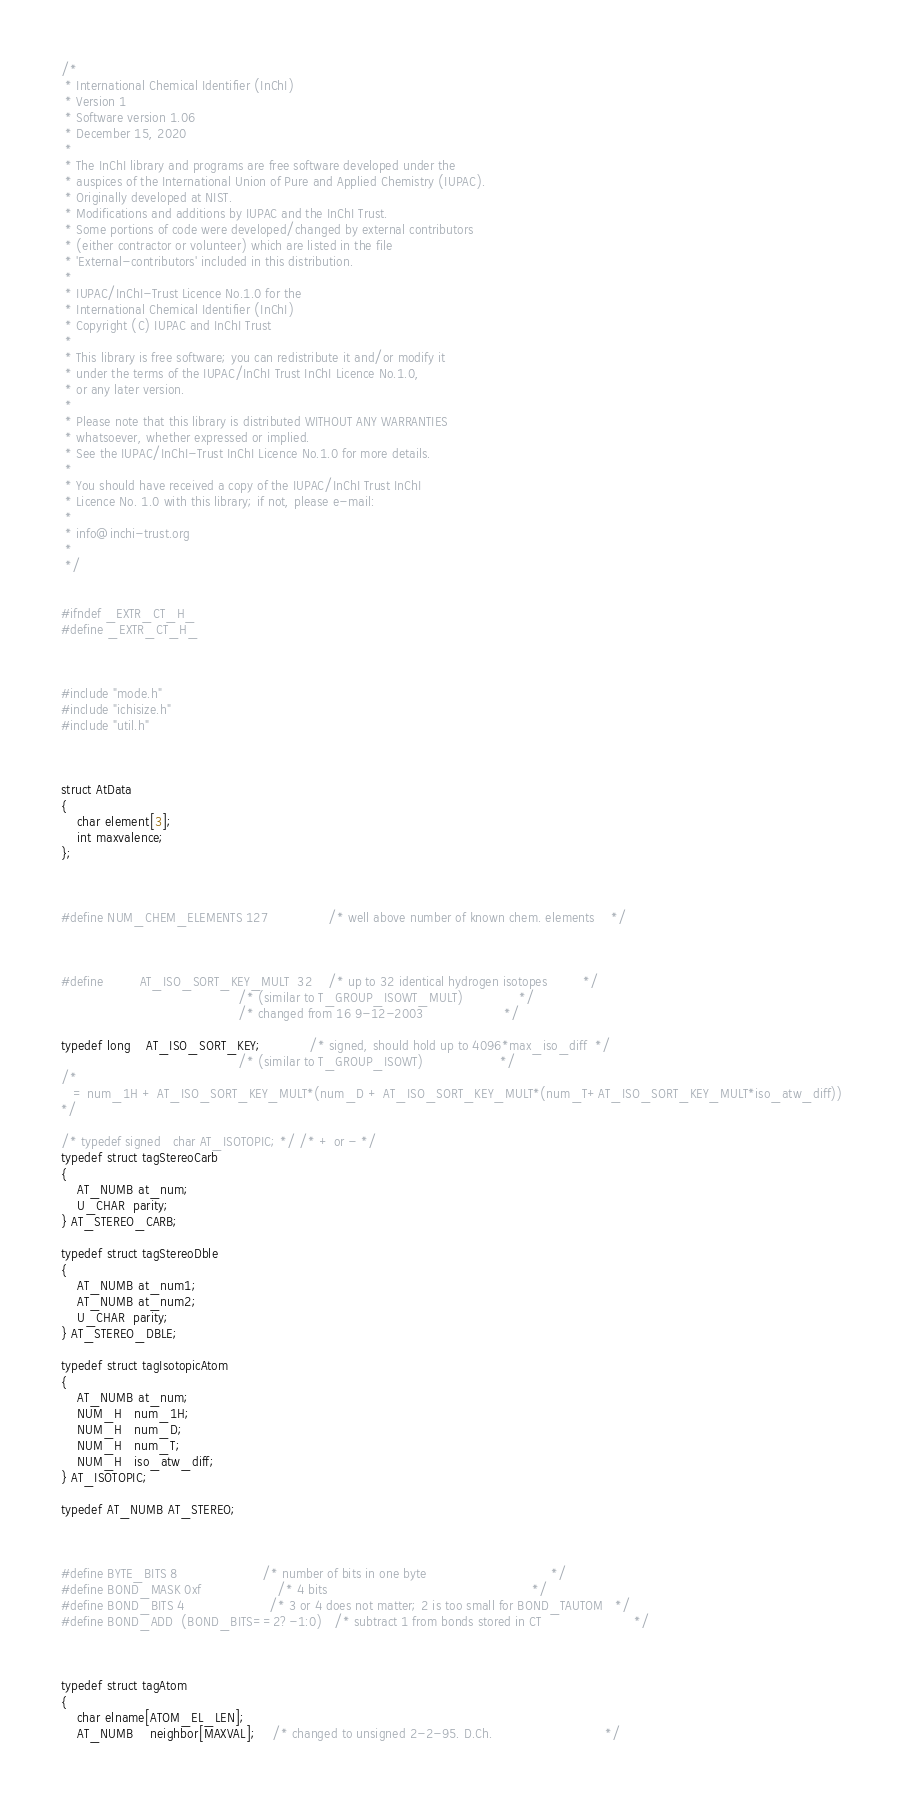<code> <loc_0><loc_0><loc_500><loc_500><_C_>/*
 * International Chemical Identifier (InChI)
 * Version 1
 * Software version 1.06
 * December 15, 2020
 *
 * The InChI library and programs are free software developed under the
 * auspices of the International Union of Pure and Applied Chemistry (IUPAC).
 * Originally developed at NIST.
 * Modifications and additions by IUPAC and the InChI Trust.
 * Some portions of code were developed/changed by external contributors
 * (either contractor or volunteer) which are listed in the file
 * 'External-contributors' included in this distribution.
 *
 * IUPAC/InChI-Trust Licence No.1.0 for the
 * International Chemical Identifier (InChI)
 * Copyright (C) IUPAC and InChI Trust
 *
 * This library is free software; you can redistribute it and/or modify it
 * under the terms of the IUPAC/InChI Trust InChI Licence No.1.0,
 * or any later version.
 *
 * Please note that this library is distributed WITHOUT ANY WARRANTIES
 * whatsoever, whether expressed or implied.
 * See the IUPAC/InChI-Trust InChI Licence No.1.0 for more details.
 *
 * You should have received a copy of the IUPAC/InChI Trust InChI
 * Licence No. 1.0 with this library; if not, please e-mail:
 *
 * info@inchi-trust.org
 *
 */


#ifndef _EXTR_CT_H_
#define _EXTR_CT_H_



#include "mode.h"
#include "ichisize.h"
#include "util.h"



struct AtData
{
    char element[3];
    int maxvalence;
};



#define NUM_CHEM_ELEMENTS 127               /* well above number of known chem. elements    */



#define         AT_ISO_SORT_KEY_MULT  32    /* up to 32 identical hydrogen isotopes         */
                                            /* (similar to T_GROUP_ISOWT_MULT)              */
                                            /* changed from 16 9-12-2003                    */

typedef long    AT_ISO_SORT_KEY;            /* signed, should hold up to 4096*max_iso_diff  */
                                            /* (similar to T_GROUP_ISOWT)                   */
/*
   = num_1H + AT_ISO_SORT_KEY_MULT*(num_D + AT_ISO_SORT_KEY_MULT*(num_T+AT_ISO_SORT_KEY_MULT*iso_atw_diff))
*/

/* typedef signed   char AT_ISOTOPIC; */ /* + or - */
typedef struct tagStereoCarb
{
    AT_NUMB at_num;
    U_CHAR  parity;
} AT_STEREO_CARB;

typedef struct tagStereoDble
{
    AT_NUMB at_num1;
    AT_NUMB at_num2;
    U_CHAR  parity;
} AT_STEREO_DBLE;

typedef struct tagIsotopicAtom
{
    AT_NUMB at_num;
    NUM_H   num_1H;
    NUM_H   num_D;
    NUM_H   num_T;
    NUM_H   iso_atw_diff;
} AT_ISOTOPIC;

typedef AT_NUMB AT_STEREO;



#define BYTE_BITS 8                     /* number of bits in one byte                               */
#define BOND_MASK 0xf                   /* 4 bits                                                   */
#define BOND_BITS 4                     /* 3 or 4 does not matter; 2 is too small for BOND_TAUTOM   */
#define BOND_ADD  (BOND_BITS==2?-1:0)   /* subtract 1 from bonds stored in CT                       */



typedef struct tagAtom
{
    char elname[ATOM_EL_LEN];
    AT_NUMB    neighbor[MAXVAL];    /* changed to unsigned 2-2-95. D.Ch.                            */</code> 